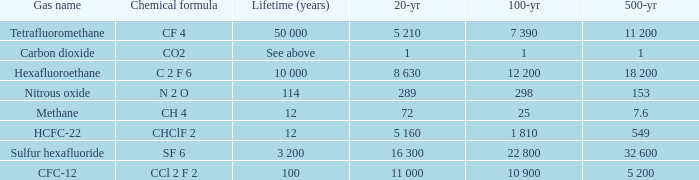What is the 100 year when 500 year is 153? 298.0. 